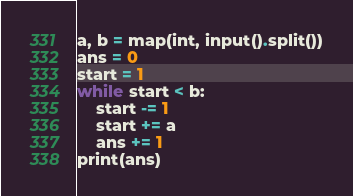<code> <loc_0><loc_0><loc_500><loc_500><_Python_>a, b = map(int, input().split())
ans = 0
start = 1
while start < b:
    start -= 1
    start += a
    ans += 1
print(ans)
</code> 